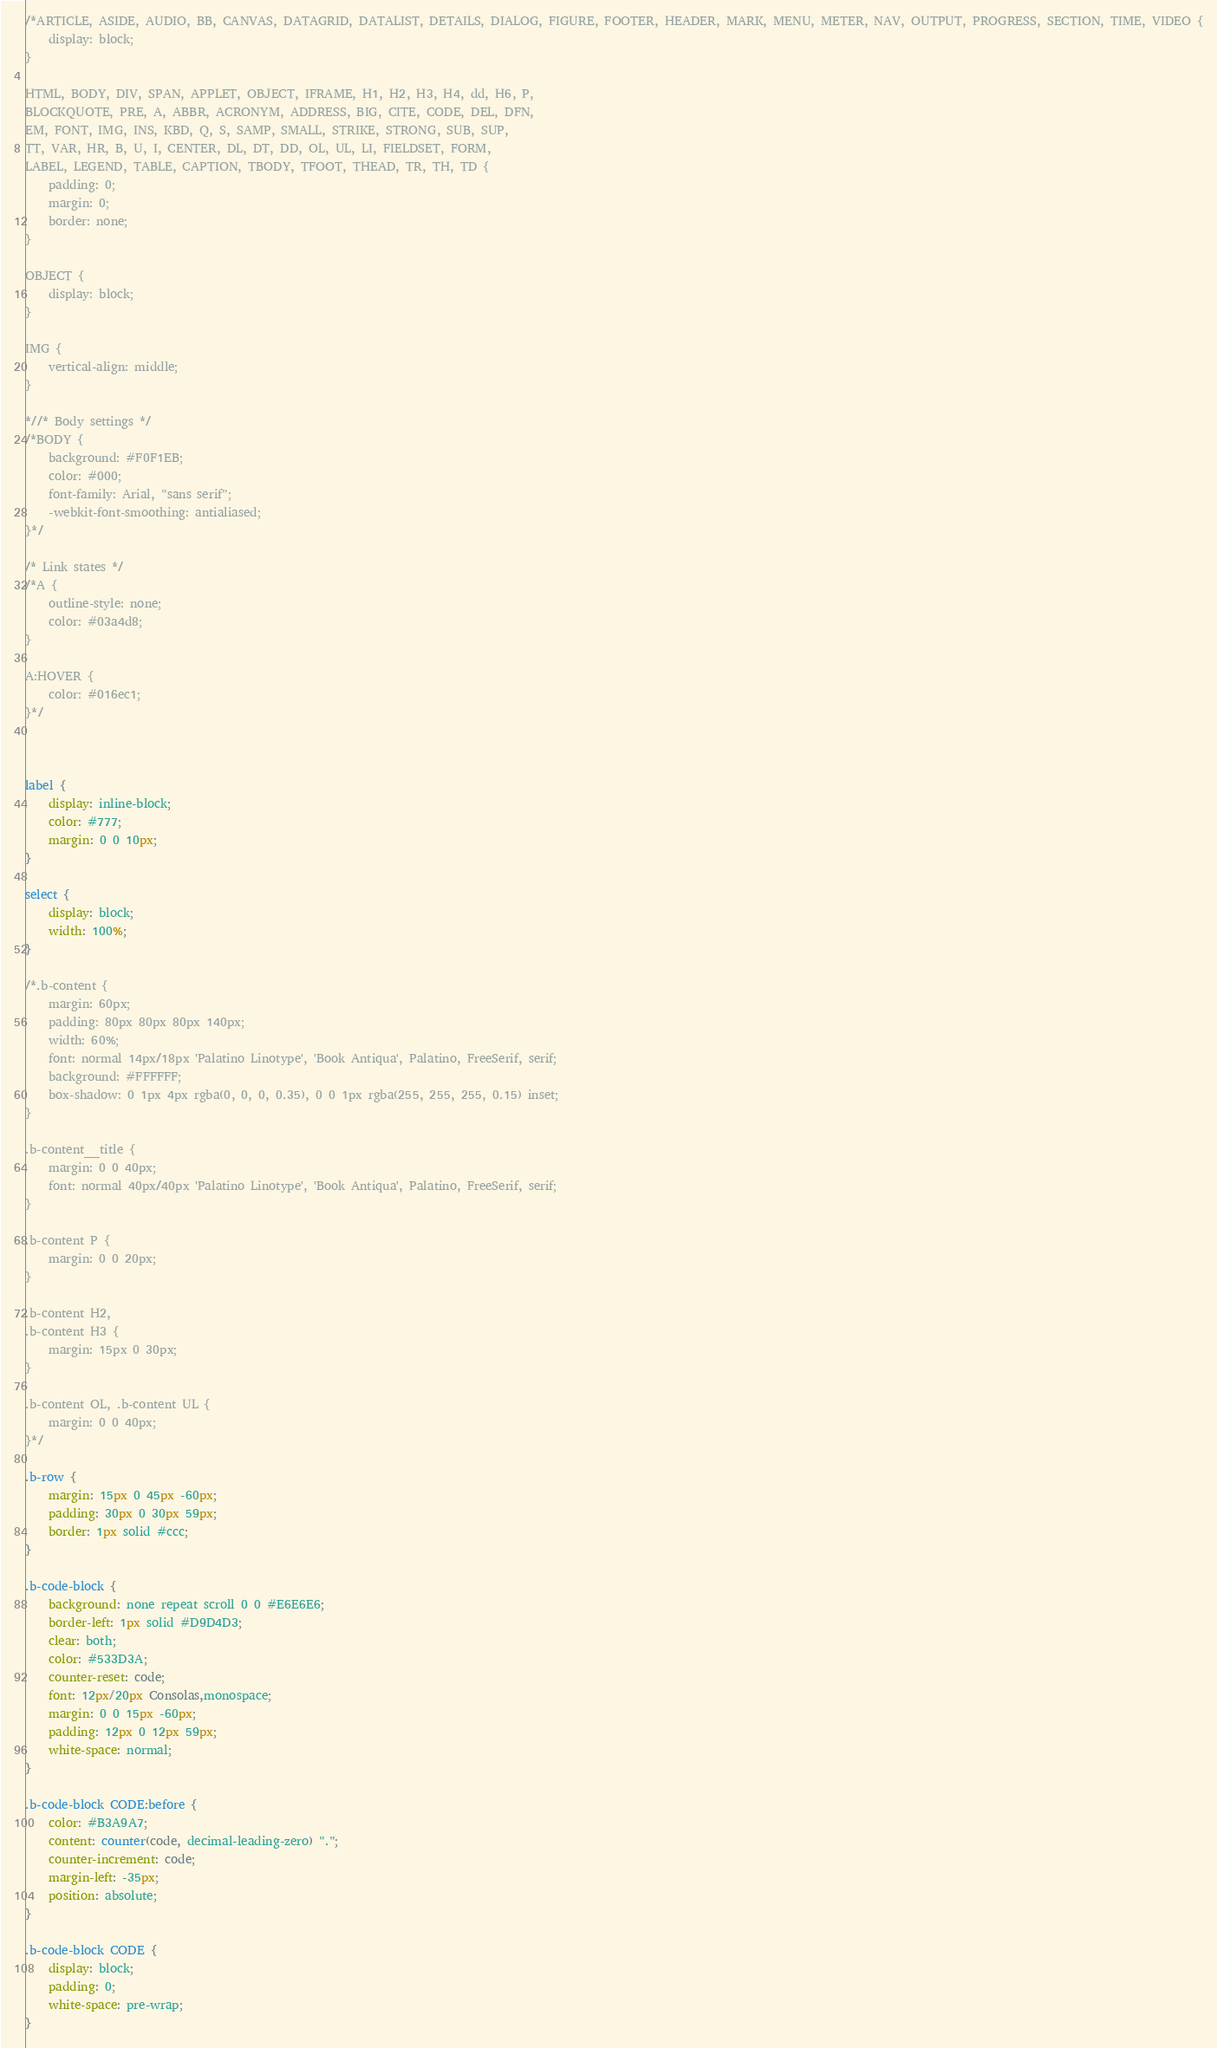<code> <loc_0><loc_0><loc_500><loc_500><_CSS_>/*ARTICLE, ASIDE, AUDIO, BB, CANVAS, DATAGRID, DATALIST, DETAILS, DIALOG, FIGURE, FOOTER, HEADER, MARK, MENU, METER, NAV, OUTPUT, PROGRESS, SECTION, TIME, VIDEO {
    display: block;
}

HTML, BODY, DIV, SPAN, APPLET, OBJECT, IFRAME, H1, H2, H3, H4, dd, H6, P,
BLOCKQUOTE, PRE, A, ABBR, ACRONYM, ADDRESS, BIG, CITE, CODE, DEL, DFN,
EM, FONT, IMG, INS, KBD, Q, S, SAMP, SMALL, STRIKE, STRONG, SUB, SUP,
TT, VAR, HR, B, U, I, CENTER, DL, DT, DD, OL, UL, LI, FIELDSET, FORM,
LABEL, LEGEND, TABLE, CAPTION, TBODY, TFOOT, THEAD, TR, TH, TD {
    padding: 0;
    margin: 0;
    border: none;
}

OBJECT {
    display: block;
}

IMG {
    vertical-align: middle;
}

*//* Body settings */
/*BODY {
    background: #F0F1EB;
    color: #000;
    font-family: Arial, "sans serif";
    -webkit-font-smoothing: antialiased;
}*/

/* Link states */
/*A {
    outline-style: none;
    color: #03a4d8;
}

A:HOVER {
    color: #016ec1;
}*/



label {
    display: inline-block;
    color: #777;
    margin: 0 0 10px;
}

select {
    display: block;
    width: 100%;
}

/*.b-content {
    margin: 60px;
    padding: 80px 80px 80px 140px;
    width: 60%;
    font: normal 14px/18px 'Palatino Linotype', 'Book Antiqua', Palatino, FreeSerif, serif;
    background: #FFFFFF;
    box-shadow: 0 1px 4px rgba(0, 0, 0, 0.35), 0 0 1px rgba(255, 255, 255, 0.15) inset;
}

.b-content__title {
    margin: 0 0 40px;
    font: normal 40px/40px 'Palatino Linotype', 'Book Antiqua', Palatino, FreeSerif, serif;
}

.b-content P {
    margin: 0 0 20px;
}

.b-content H2,
.b-content H3 {
    margin: 15px 0 30px;
}

.b-content OL, .b-content UL {
    margin: 0 0 40px;
}*/

.b-row {
    margin: 15px 0 45px -60px;
    padding: 30px 0 30px 59px;
    border: 1px solid #ccc;
}

.b-code-block {
    background: none repeat scroll 0 0 #E6E6E6;
    border-left: 1px solid #D9D4D3;
    clear: both;
    color: #533D3A;
    counter-reset: code;
    font: 12px/20px Consolas,monospace;
    margin: 0 0 15px -60px;
    padding: 12px 0 12px 59px;
    white-space: normal;
}

.b-code-block CODE:before {
    color: #B3A9A7;
    content: counter(code, decimal-leading-zero) ".";
    counter-increment: code;
    margin-left: -35px;
    position: absolute;
}

.b-code-block CODE {
    display: block;
    padding: 0;
    white-space: pre-wrap;
}</code> 